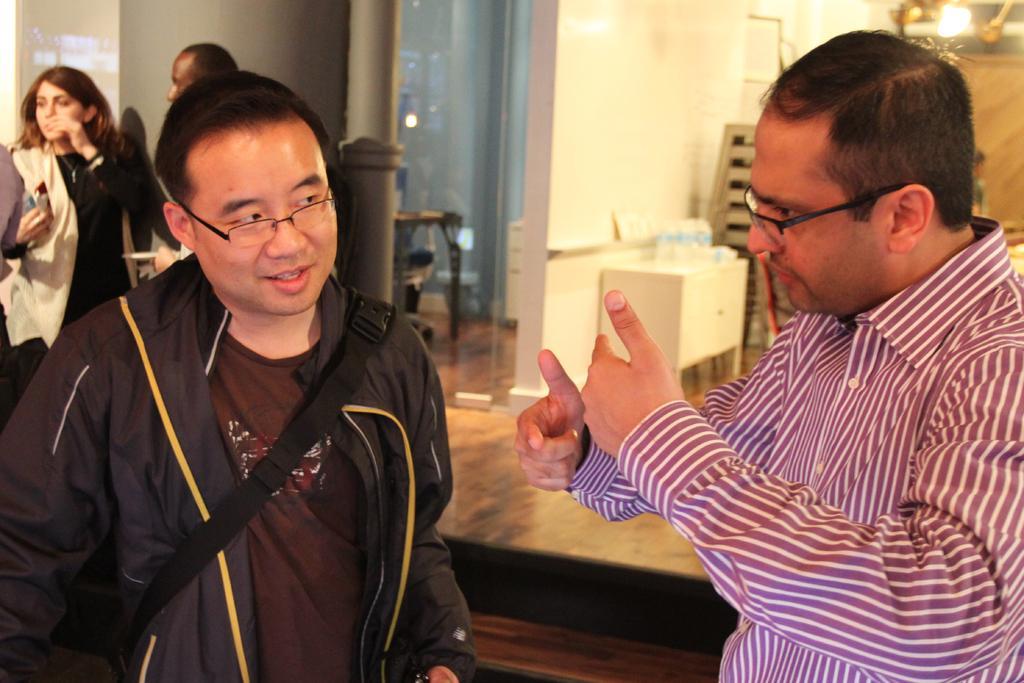Please provide a concise description of this image. In this picture i can see two men are standing and wearing spectacles. In the background i can see lights, wall and some other objects on the floor. On the left side i can see a woman and a man are standing. 